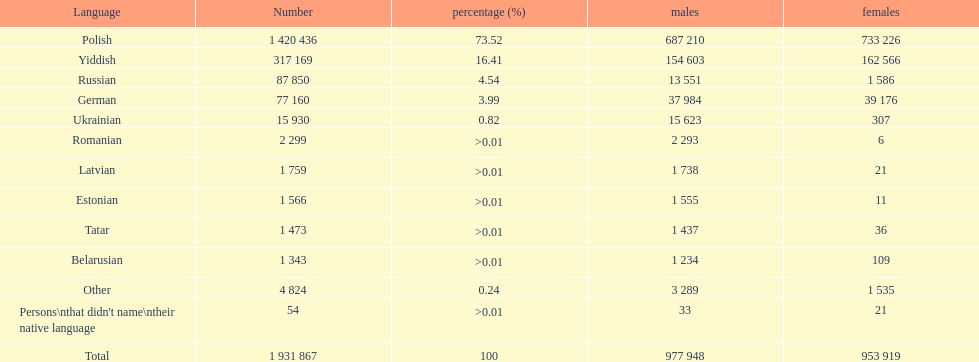Which language had the least number of females speaking it? Romanian. 